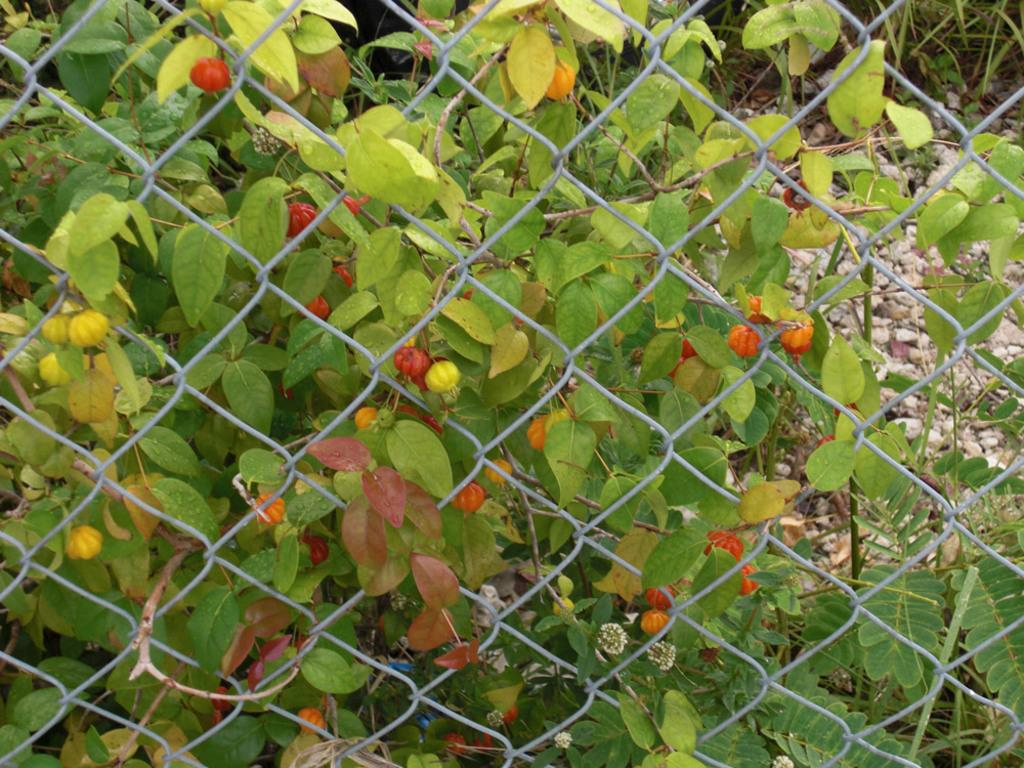What type of structure can be seen in the image? There is fencing in the image. What can be seen in the background of the image? Green leaves, stones, and grass are visible in the background of the image. Where is the sofa located in the image? There is no sofa present in the image. What type of lettuce can be seen growing in the background of the image? There is no lettuce visible in the image; only green leaves, stones, and grass are present in the background. 